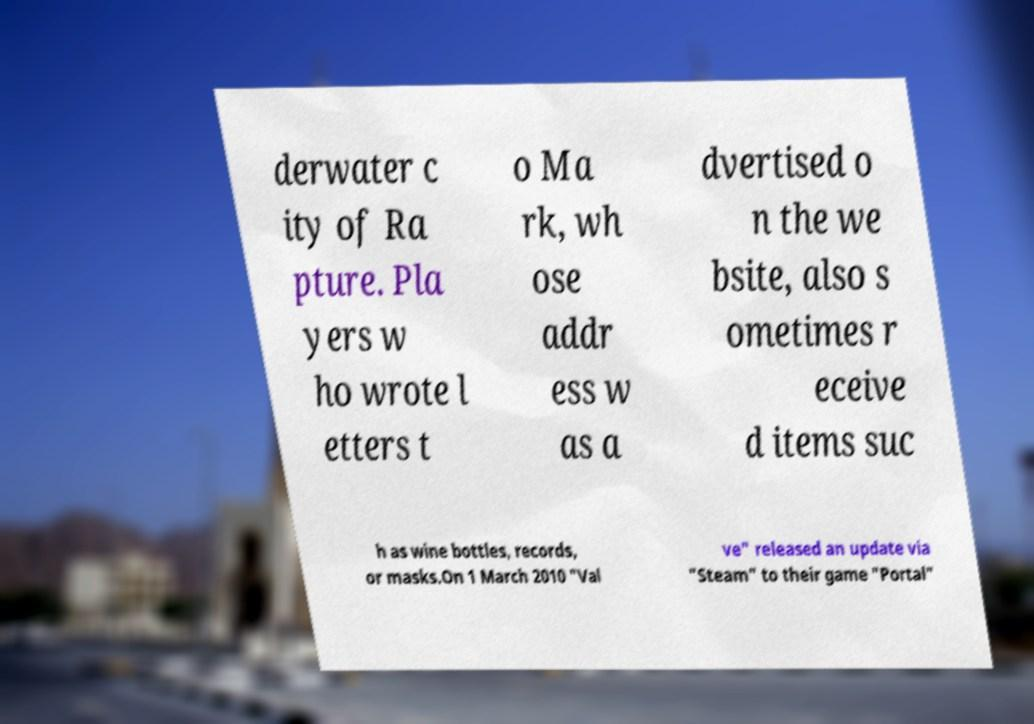For documentation purposes, I need the text within this image transcribed. Could you provide that? derwater c ity of Ra pture. Pla yers w ho wrote l etters t o Ma rk, wh ose addr ess w as a dvertised o n the we bsite, also s ometimes r eceive d items suc h as wine bottles, records, or masks.On 1 March 2010 "Val ve" released an update via "Steam" to their game "Portal" 